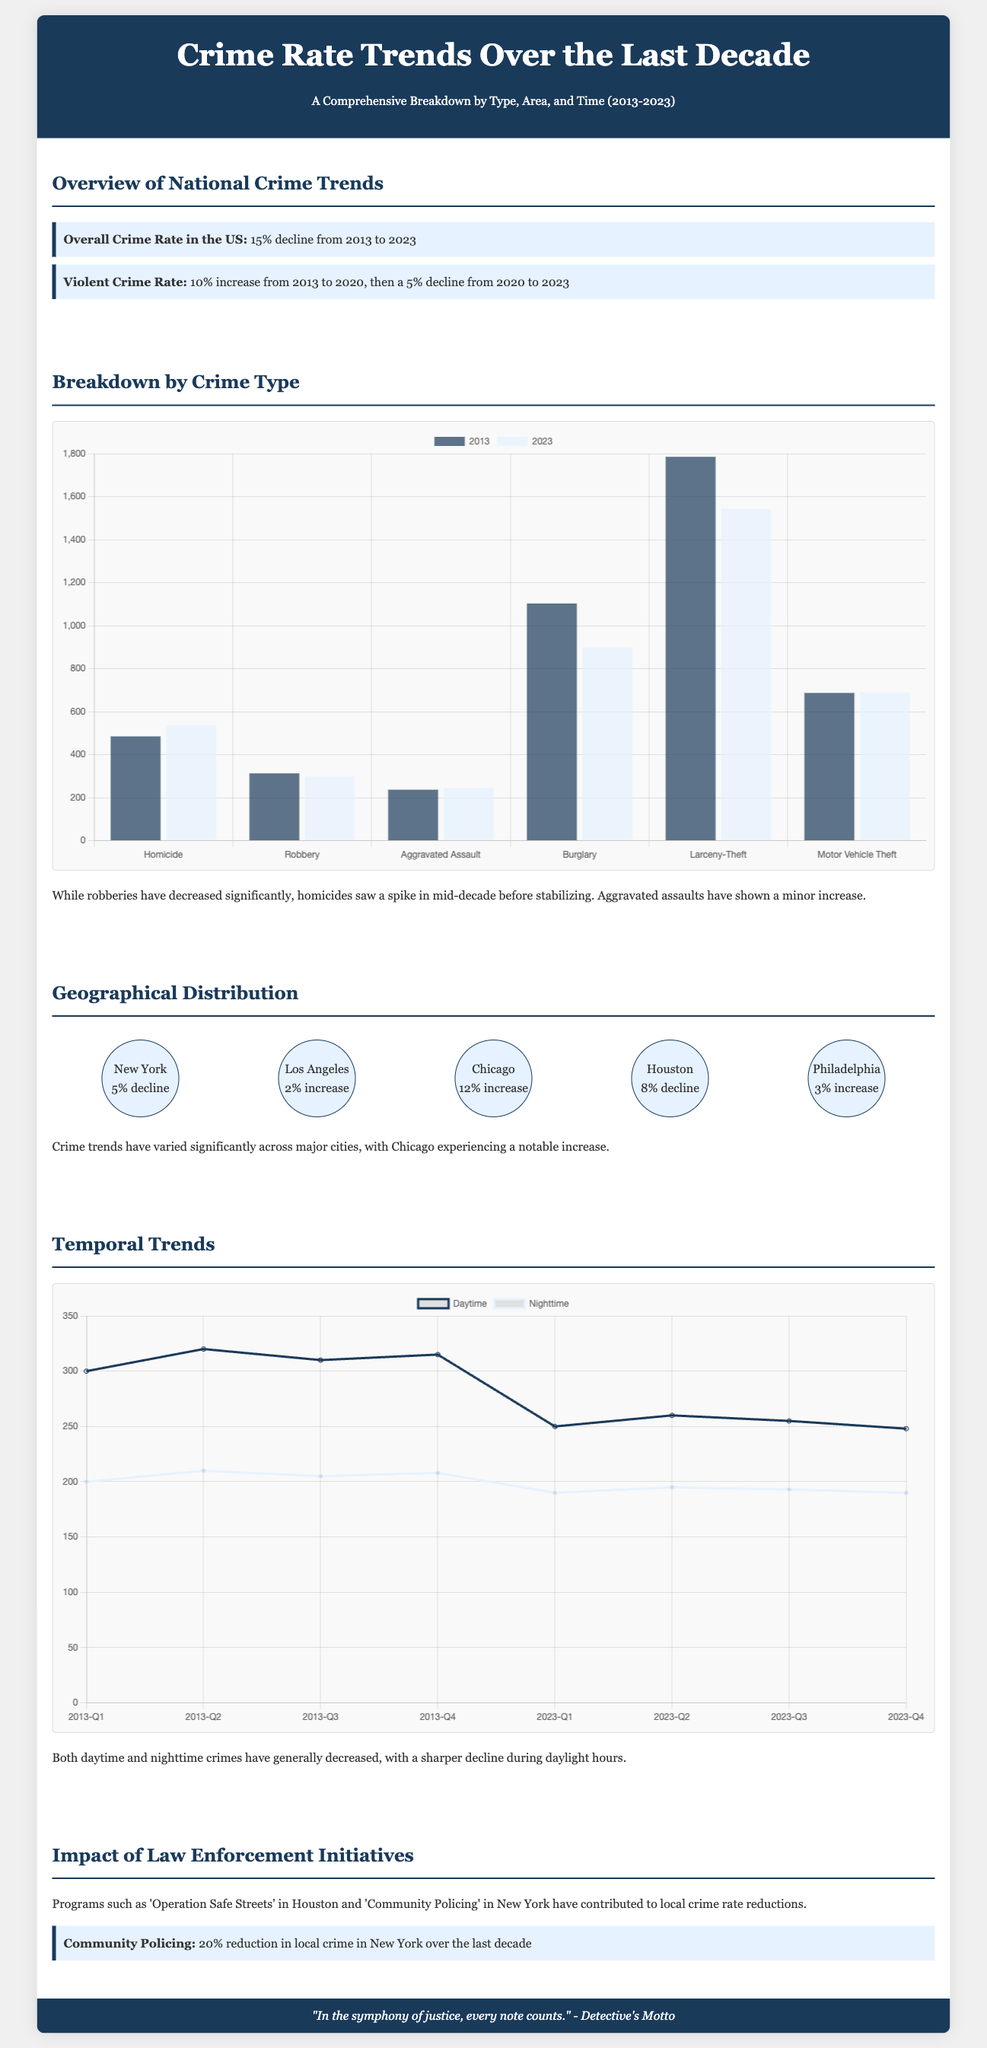What was the overall crime rate change in the US from 2013 to 2023? The overall crime rate in the US experienced a 15% decline over the decade.
Answer: 15% decline What type of crime saw a 10% increase from 2013 to 2020? The document states that the violent crime rate increased by 10% during this period.
Answer: Violent Crime Which city had a 12% increase in crime? The infographic lists Chicago as experiencing a 12% increase in crime.
Answer: Chicago What was the decline percentage of crimes in New York due to community policing? The document notes a 20% reduction in local crime in New York attributed to community policing initiatives.
Answer: 20% How did daytime crimes trend compared to nighttime crimes generally? The document indicates both daytime and nighttime crimes have generally decreased, with daytime crimes showing a sharper decline.
Answer: Decreased What was the percentage change in robbery from 2013 to 2023? The data from the chart shows robbery decreased from 313 to 298 over the decade.
Answer: Decreased Which initiative contributed to the reduction of local crime in Houston? The document mentions 'Operation Safe Streets' as a program that contributed to crime reduction in Houston.
Answer: Operation Safe Streets What type of chart is used to represent crime rates by type? The infographic employs a bar chart to display crime rates by type for the years 2013 and 2023.
Answer: Bar chart 